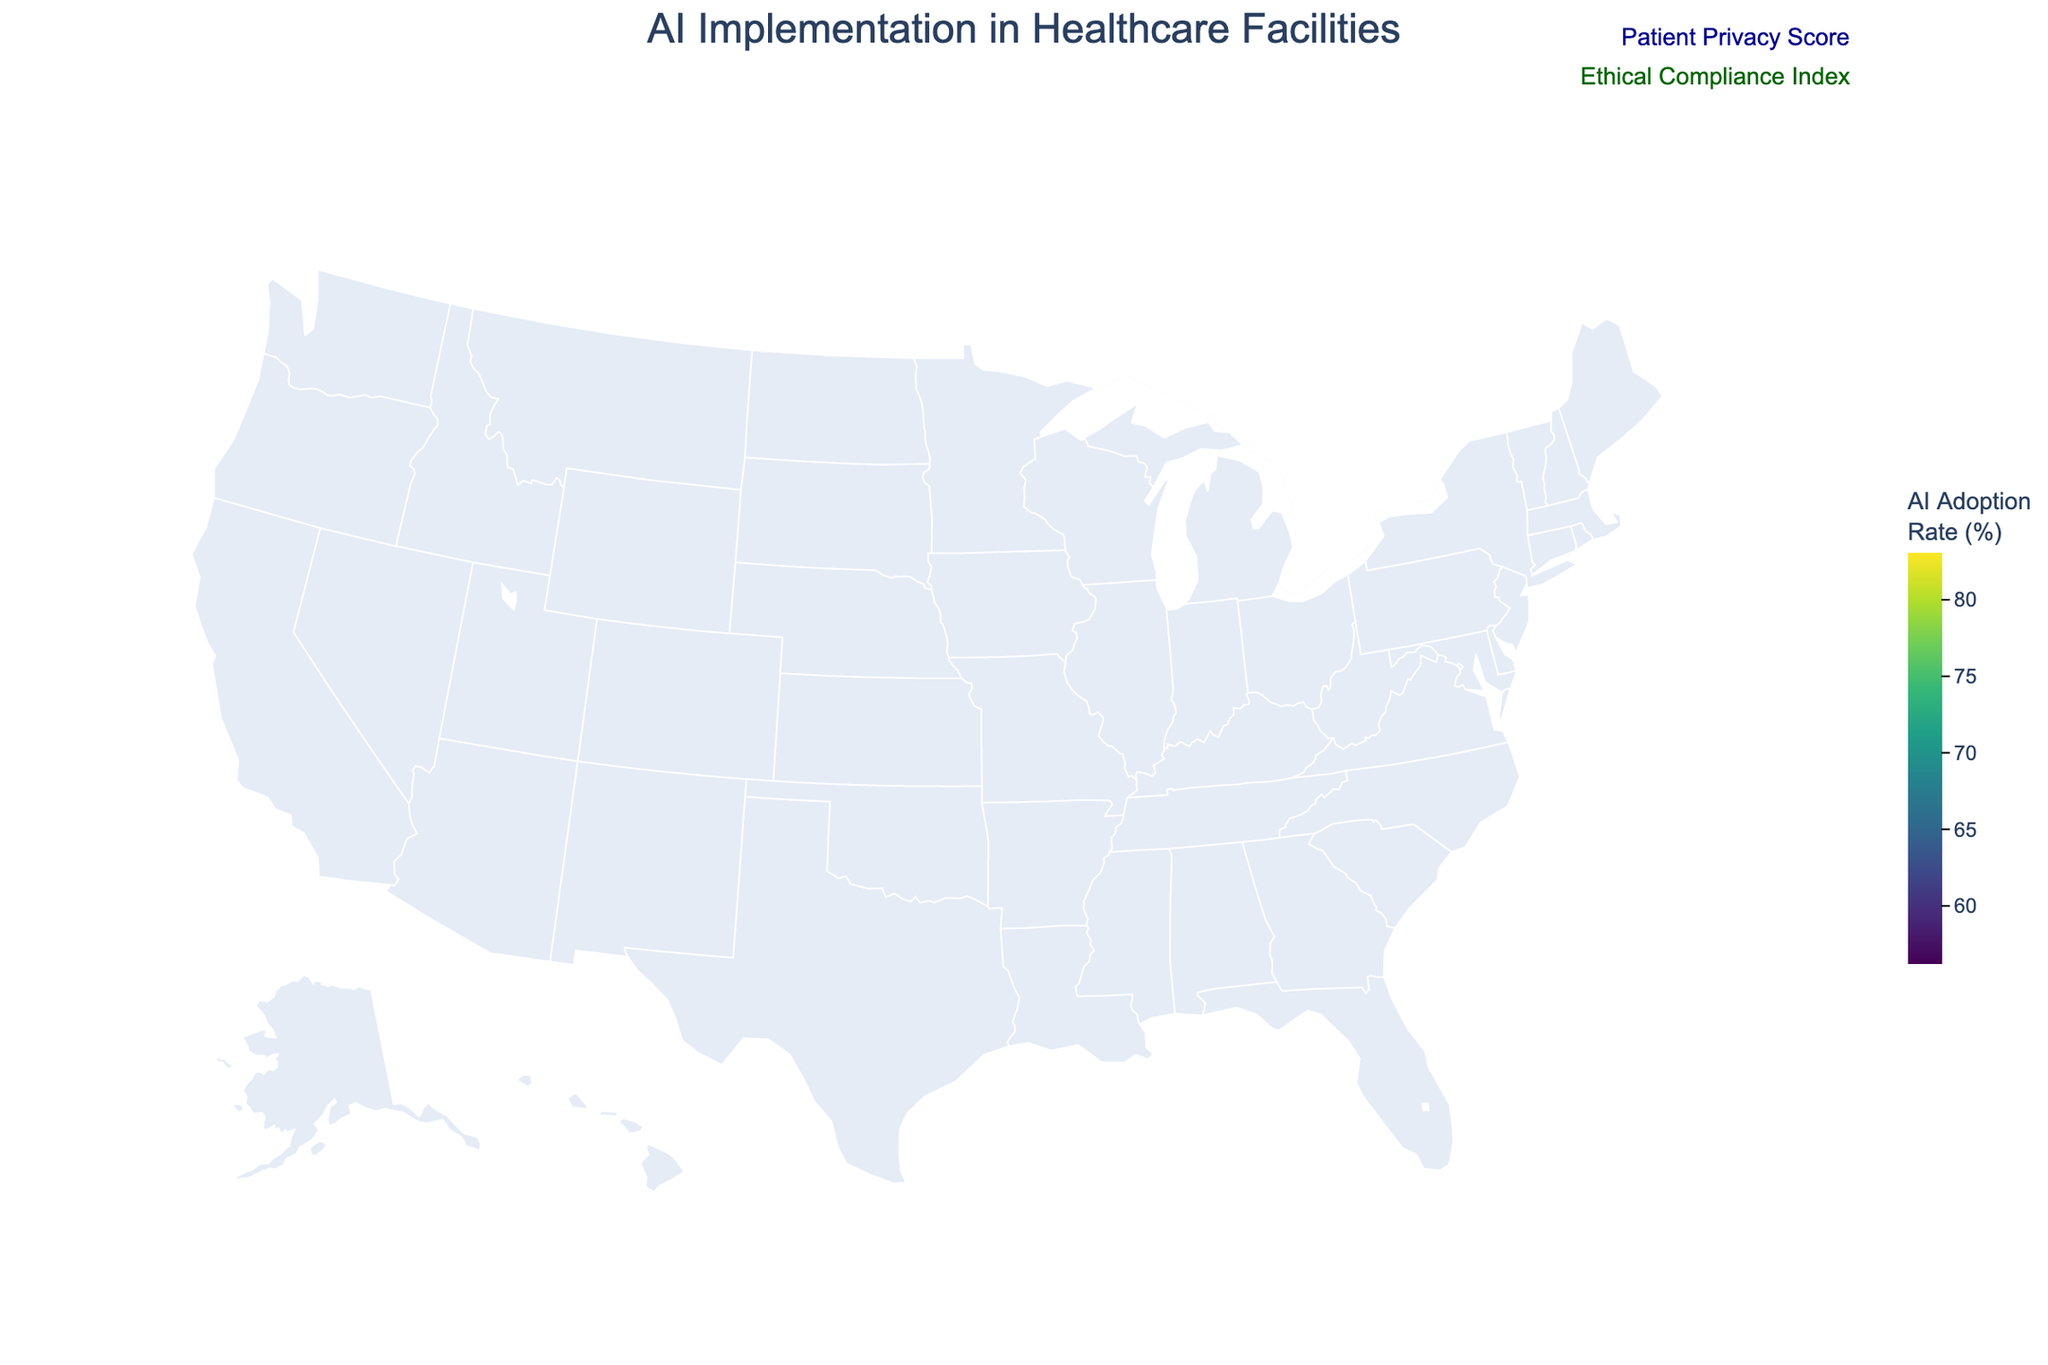Which state has the highest AI adoption rate? The figure title provides the AI adoption rates for each state. The state with the highest percentage is listed in the data.
Answer: Massachusetts Which three states have the lowest AI adoption rates? Review the data on the figure to identify the states with the lowest percentages.
Answer: Georgia, North Carolina, Ohio What is the average AI adoption rate across all states? Sum the AI adoption rates and divide by the number of states (15). The sum is (78.5 + 72.3 + 65.8 + 69.2 + 61.7 + 83.1 + 76.4 + 80.9 + 58.3 + 63.5 + 59.8 + 67.1 + 56.2 + 70.6 + 74.8) = 1037.2. Hence, the average is 1037.2/15 = 69.15.
Answer: 69.15 Which state with a Patient Privacy Score above 90 has the lowest AI adoption rate? Identify states with a Patient Privacy Score above 90 and then find the one with the lowest AI adoption rate among them. Data shows Illinois with a Patient Privacy Score of 90 and AI Adoption Rate of 61.7.
Answer: Illinois Compare the AI adoption rates between California and Texas. Which is higher, and by how much? Review the AI adoption rates for California and Texas. California has 78.5%, Texas has 65.8%. Subtract Texas's rate from California's rate (78.5 - 65.8).
Answer: California is higher by 12.7% Is there a correlation between the AI Adoption Rate and Patient Privacy Score? This requires examining if there's a pattern in the figure's hover data, showing whether higher AI Adoption Rate typically aligns with higher Patient Privacy Scores. Visual inspection can indicate a general positive correlation, but precise correlation calculation would need numeric analysis.
Answer: There appears to be a positive correlation What is the Ethical Compliance Index for the state with the highest AI adoption rate? Massachusetts has the highest AI adoption rate. Review the hover data for Massachusetts to find its Ethical Compliance Index, which is 91.
Answer: 91 